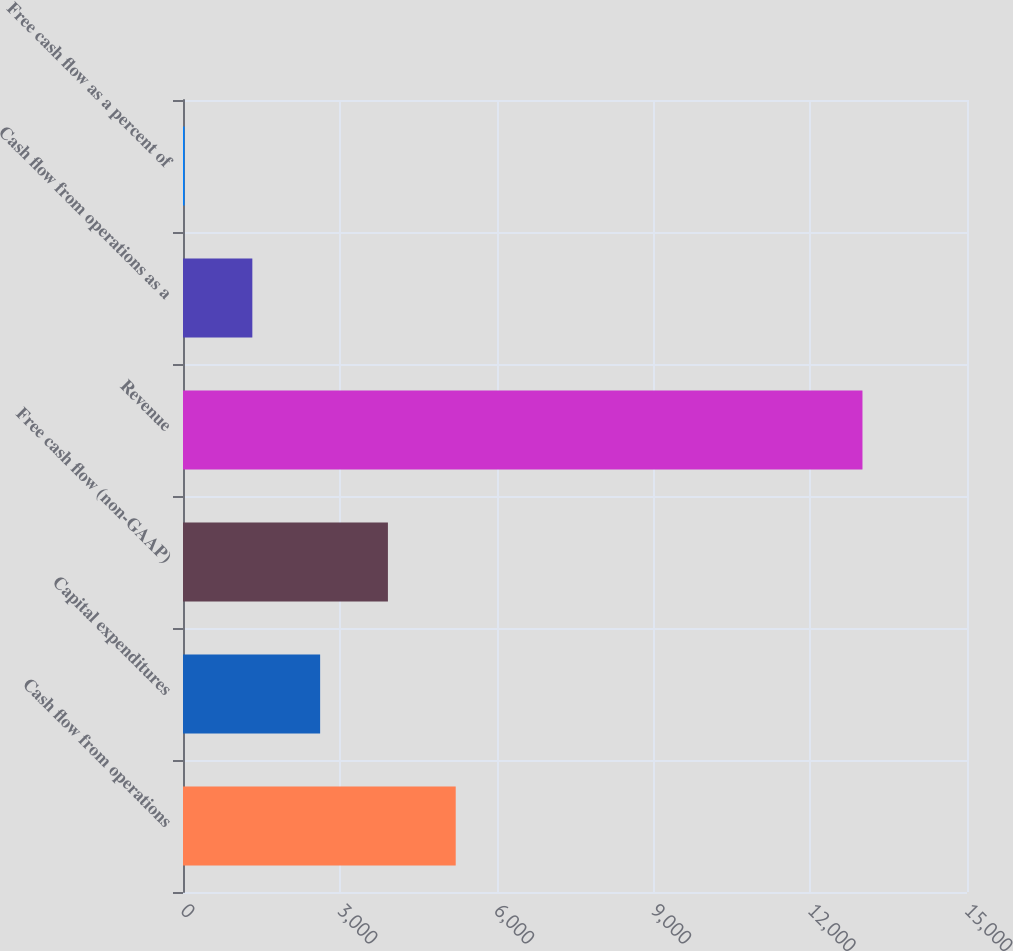<chart> <loc_0><loc_0><loc_500><loc_500><bar_chart><fcel>Cash flow from operations<fcel>Capital expenditures<fcel>Free cash flow (non-GAAP)<fcel>Revenue<fcel>Cash flow from operations as a<fcel>Free cash flow as a percent of<nl><fcel>5217.76<fcel>2623.68<fcel>3920.72<fcel>13000<fcel>1326.64<fcel>29.6<nl></chart> 